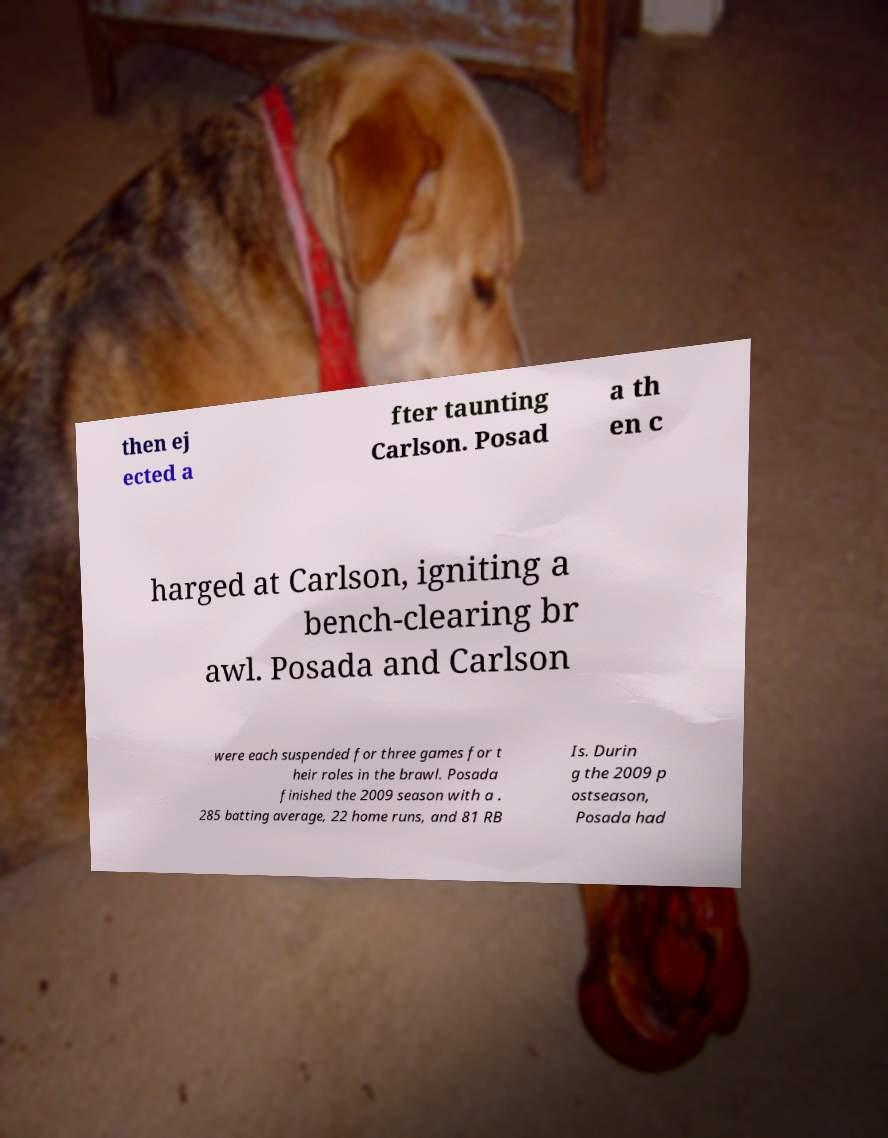Can you accurately transcribe the text from the provided image for me? then ej ected a fter taunting Carlson. Posad a th en c harged at Carlson, igniting a bench-clearing br awl. Posada and Carlson were each suspended for three games for t heir roles in the brawl. Posada finished the 2009 season with a . 285 batting average, 22 home runs, and 81 RB Is. Durin g the 2009 p ostseason, Posada had 